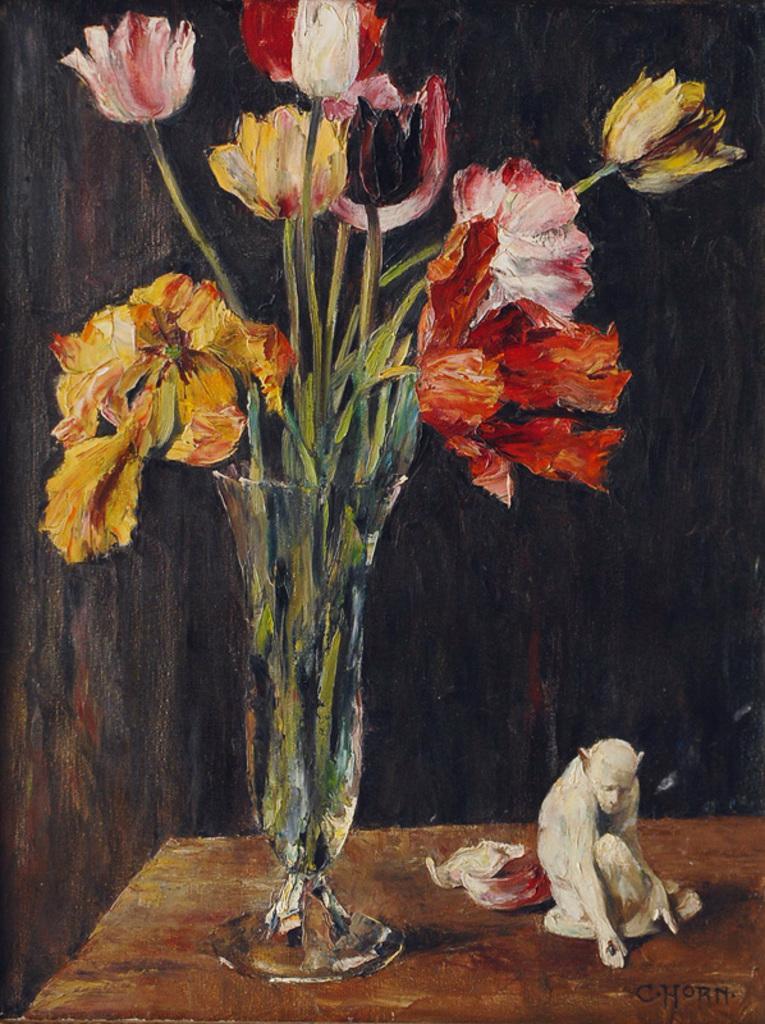Please provide a concise description of this image. In this image I can see a flower vase and different color flowers. I can see white color statue on the brown color table. Background is in black color. 